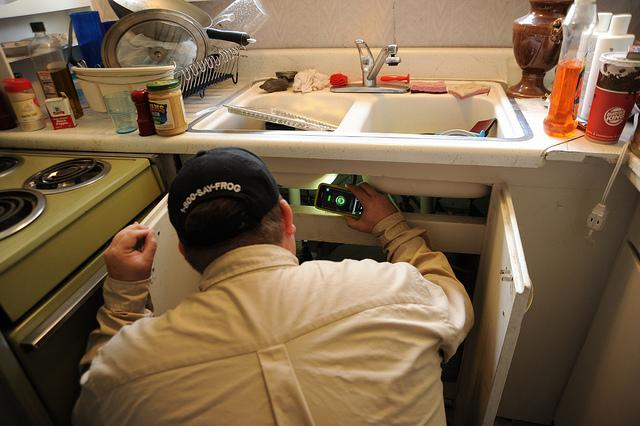What is the man using the phone as?

Choices:
A) flash light
B) speaker
C) television
D) blender flash light 